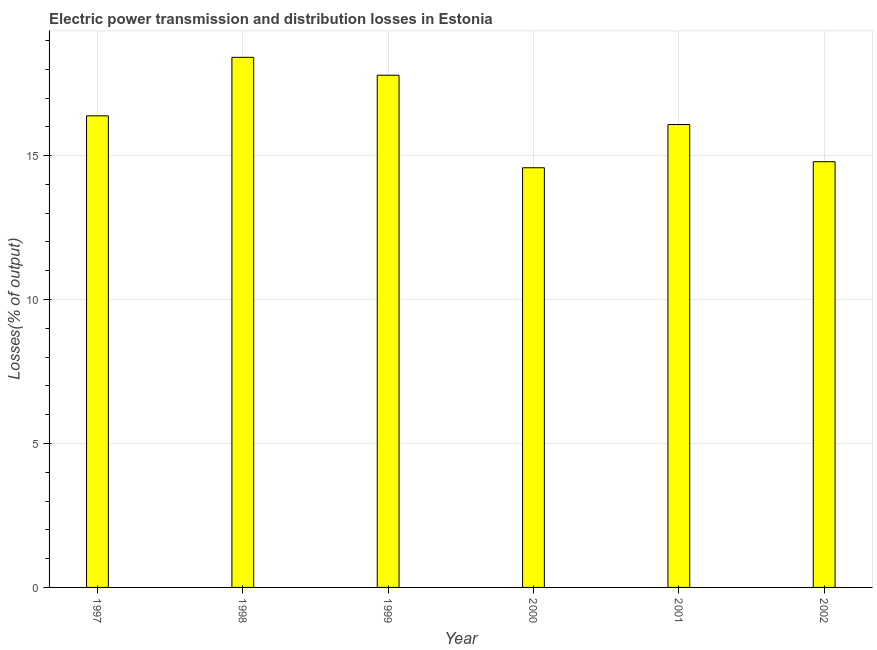Does the graph contain any zero values?
Make the answer very short. No. Does the graph contain grids?
Give a very brief answer. Yes. What is the title of the graph?
Your answer should be compact. Electric power transmission and distribution losses in Estonia. What is the label or title of the X-axis?
Give a very brief answer. Year. What is the label or title of the Y-axis?
Ensure brevity in your answer.  Losses(% of output). What is the electric power transmission and distribution losses in 1999?
Provide a short and direct response. 17.79. Across all years, what is the maximum electric power transmission and distribution losses?
Offer a very short reply. 18.41. Across all years, what is the minimum electric power transmission and distribution losses?
Provide a short and direct response. 14.58. What is the sum of the electric power transmission and distribution losses?
Make the answer very short. 98.03. What is the difference between the electric power transmission and distribution losses in 1998 and 2002?
Provide a succinct answer. 3.62. What is the average electric power transmission and distribution losses per year?
Provide a succinct answer. 16.34. What is the median electric power transmission and distribution losses?
Give a very brief answer. 16.23. In how many years, is the electric power transmission and distribution losses greater than 11 %?
Provide a succinct answer. 6. Do a majority of the years between 2002 and 1997 (inclusive) have electric power transmission and distribution losses greater than 5 %?
Your answer should be compact. Yes. What is the ratio of the electric power transmission and distribution losses in 1997 to that in 1999?
Provide a succinct answer. 0.92. Is the electric power transmission and distribution losses in 1998 less than that in 2000?
Your response must be concise. No. What is the difference between the highest and the second highest electric power transmission and distribution losses?
Keep it short and to the point. 0.62. Is the sum of the electric power transmission and distribution losses in 1998 and 1999 greater than the maximum electric power transmission and distribution losses across all years?
Offer a very short reply. Yes. What is the difference between the highest and the lowest electric power transmission and distribution losses?
Make the answer very short. 3.84. In how many years, is the electric power transmission and distribution losses greater than the average electric power transmission and distribution losses taken over all years?
Your answer should be compact. 3. How many bars are there?
Offer a terse response. 6. Are all the bars in the graph horizontal?
Give a very brief answer. No. How many years are there in the graph?
Make the answer very short. 6. Are the values on the major ticks of Y-axis written in scientific E-notation?
Give a very brief answer. No. What is the Losses(% of output) in 1997?
Your answer should be compact. 16.38. What is the Losses(% of output) in 1998?
Offer a terse response. 18.41. What is the Losses(% of output) in 1999?
Provide a succinct answer. 17.79. What is the Losses(% of output) in 2000?
Ensure brevity in your answer.  14.58. What is the Losses(% of output) of 2001?
Provide a short and direct response. 16.08. What is the Losses(% of output) in 2002?
Your answer should be compact. 14.79. What is the difference between the Losses(% of output) in 1997 and 1998?
Provide a short and direct response. -2.03. What is the difference between the Losses(% of output) in 1997 and 1999?
Give a very brief answer. -1.41. What is the difference between the Losses(% of output) in 1997 and 2000?
Provide a succinct answer. 1.8. What is the difference between the Losses(% of output) in 1997 and 2001?
Provide a short and direct response. 0.3. What is the difference between the Losses(% of output) in 1997 and 2002?
Your answer should be compact. 1.59. What is the difference between the Losses(% of output) in 1998 and 1999?
Your answer should be very brief. 0.62. What is the difference between the Losses(% of output) in 1998 and 2000?
Provide a succinct answer. 3.84. What is the difference between the Losses(% of output) in 1998 and 2001?
Ensure brevity in your answer.  2.33. What is the difference between the Losses(% of output) in 1998 and 2002?
Offer a very short reply. 3.63. What is the difference between the Losses(% of output) in 1999 and 2000?
Provide a short and direct response. 3.21. What is the difference between the Losses(% of output) in 1999 and 2001?
Make the answer very short. 1.71. What is the difference between the Losses(% of output) in 1999 and 2002?
Provide a short and direct response. 3. What is the difference between the Losses(% of output) in 2000 and 2001?
Make the answer very short. -1.5. What is the difference between the Losses(% of output) in 2000 and 2002?
Provide a succinct answer. -0.21. What is the difference between the Losses(% of output) in 2001 and 2002?
Provide a succinct answer. 1.29. What is the ratio of the Losses(% of output) in 1997 to that in 1998?
Your answer should be very brief. 0.89. What is the ratio of the Losses(% of output) in 1997 to that in 1999?
Offer a very short reply. 0.92. What is the ratio of the Losses(% of output) in 1997 to that in 2000?
Offer a very short reply. 1.12. What is the ratio of the Losses(% of output) in 1997 to that in 2001?
Offer a terse response. 1.02. What is the ratio of the Losses(% of output) in 1997 to that in 2002?
Ensure brevity in your answer.  1.11. What is the ratio of the Losses(% of output) in 1998 to that in 1999?
Provide a succinct answer. 1.03. What is the ratio of the Losses(% of output) in 1998 to that in 2000?
Offer a very short reply. 1.26. What is the ratio of the Losses(% of output) in 1998 to that in 2001?
Make the answer very short. 1.15. What is the ratio of the Losses(% of output) in 1998 to that in 2002?
Your answer should be compact. 1.25. What is the ratio of the Losses(% of output) in 1999 to that in 2000?
Your response must be concise. 1.22. What is the ratio of the Losses(% of output) in 1999 to that in 2001?
Your answer should be compact. 1.11. What is the ratio of the Losses(% of output) in 1999 to that in 2002?
Provide a succinct answer. 1.2. What is the ratio of the Losses(% of output) in 2000 to that in 2001?
Your response must be concise. 0.91. What is the ratio of the Losses(% of output) in 2000 to that in 2002?
Your answer should be compact. 0.99. What is the ratio of the Losses(% of output) in 2001 to that in 2002?
Make the answer very short. 1.09. 